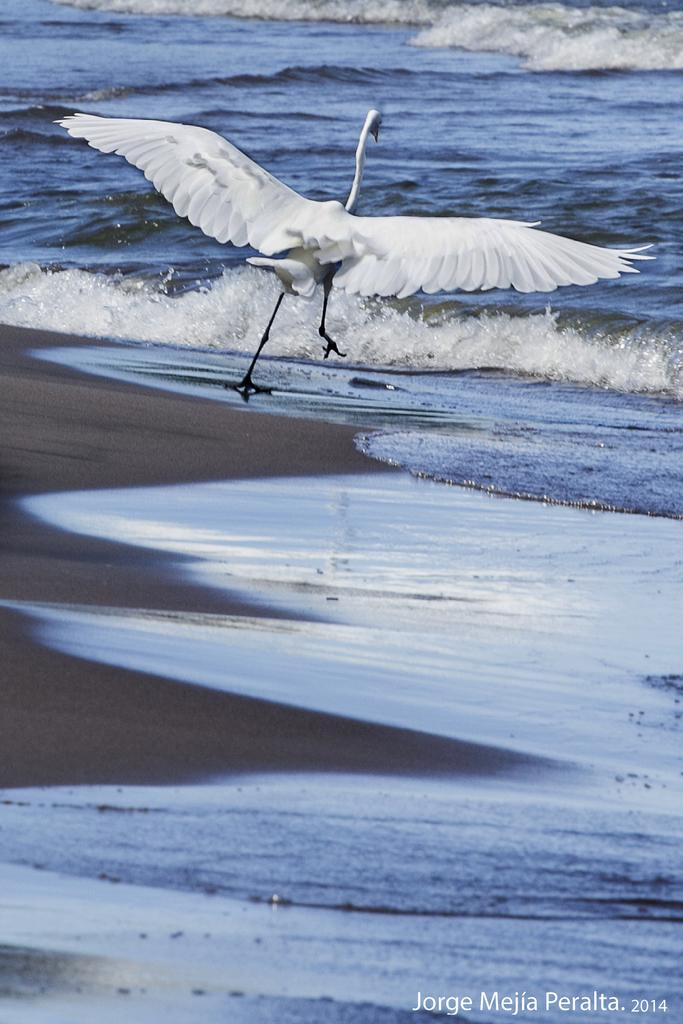What is the main subject of the image? There is a crane in the image. Where is the crane located? The crane is on the surface of the water. Is there any additional information or markings on the image? Yes, there is a watermark at the bottom of the image. How many bikes are parked near the crane in the image? There are no bikes present in the image; it features a crane on the surface of the water. What type of offer is being made by the crane in the image? There is no offer being made by the crane in the image; it is a stationary object on the water. 